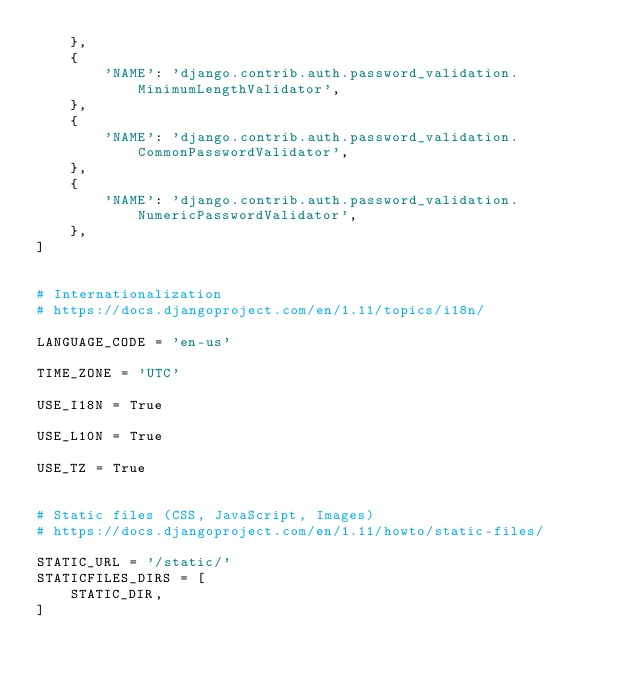<code> <loc_0><loc_0><loc_500><loc_500><_Python_>    },
    {
        'NAME': 'django.contrib.auth.password_validation.MinimumLengthValidator',
    },
    {
        'NAME': 'django.contrib.auth.password_validation.CommonPasswordValidator',
    },
    {
        'NAME': 'django.contrib.auth.password_validation.NumericPasswordValidator',
    },
]


# Internationalization
# https://docs.djangoproject.com/en/1.11/topics/i18n/

LANGUAGE_CODE = 'en-us'

TIME_ZONE = 'UTC'

USE_I18N = True

USE_L10N = True

USE_TZ = True


# Static files (CSS, JavaScript, Images)
# https://docs.djangoproject.com/en/1.11/howto/static-files/

STATIC_URL = '/static/'
STATICFILES_DIRS = [
    STATIC_DIR,
]</code> 